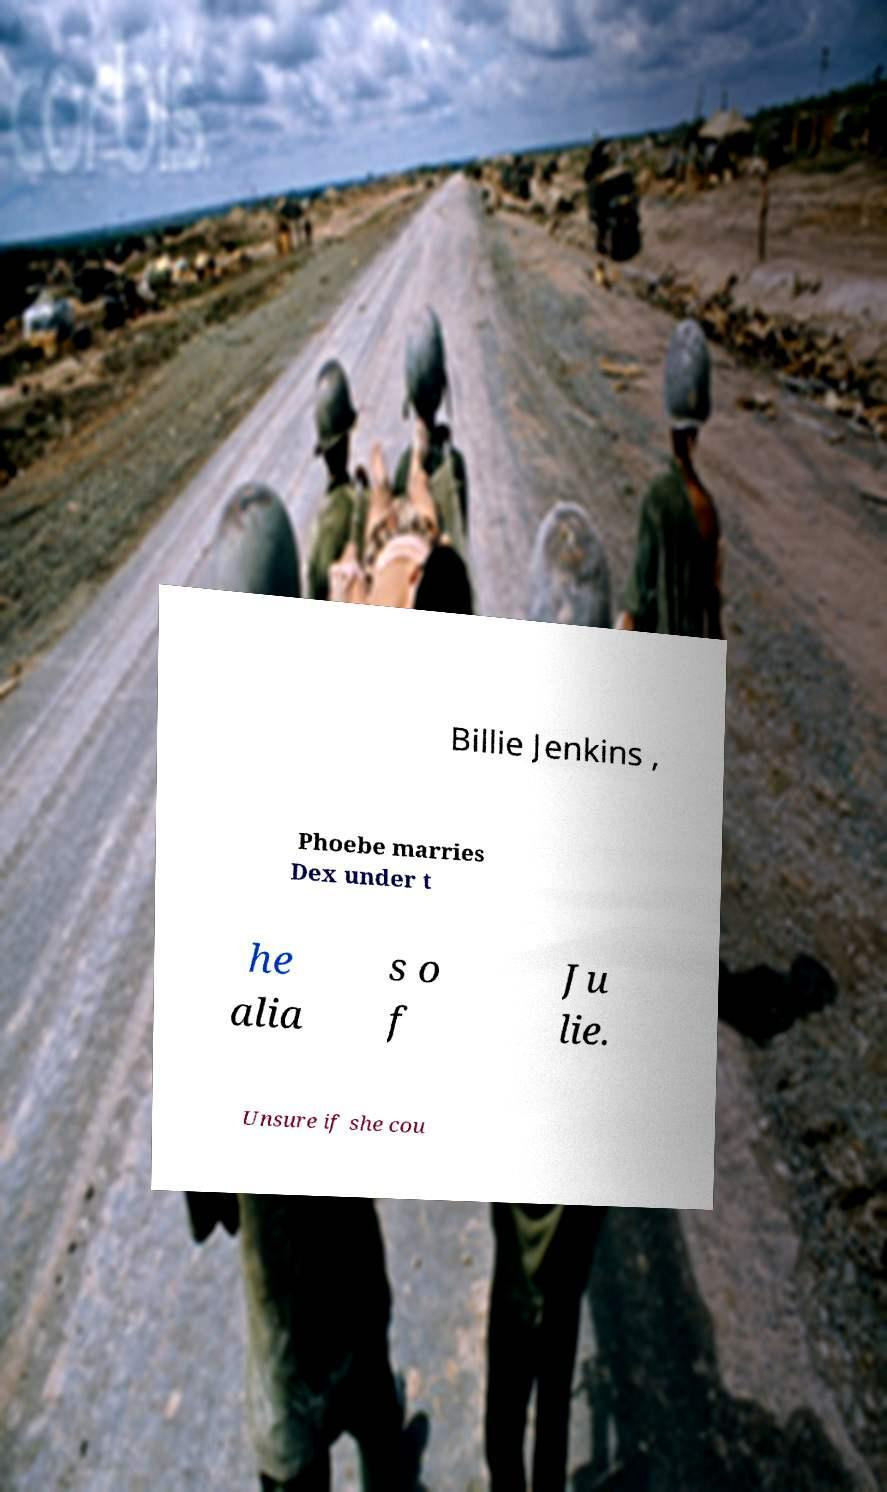Can you accurately transcribe the text from the provided image for me? Billie Jenkins , Phoebe marries Dex under t he alia s o f Ju lie. Unsure if she cou 